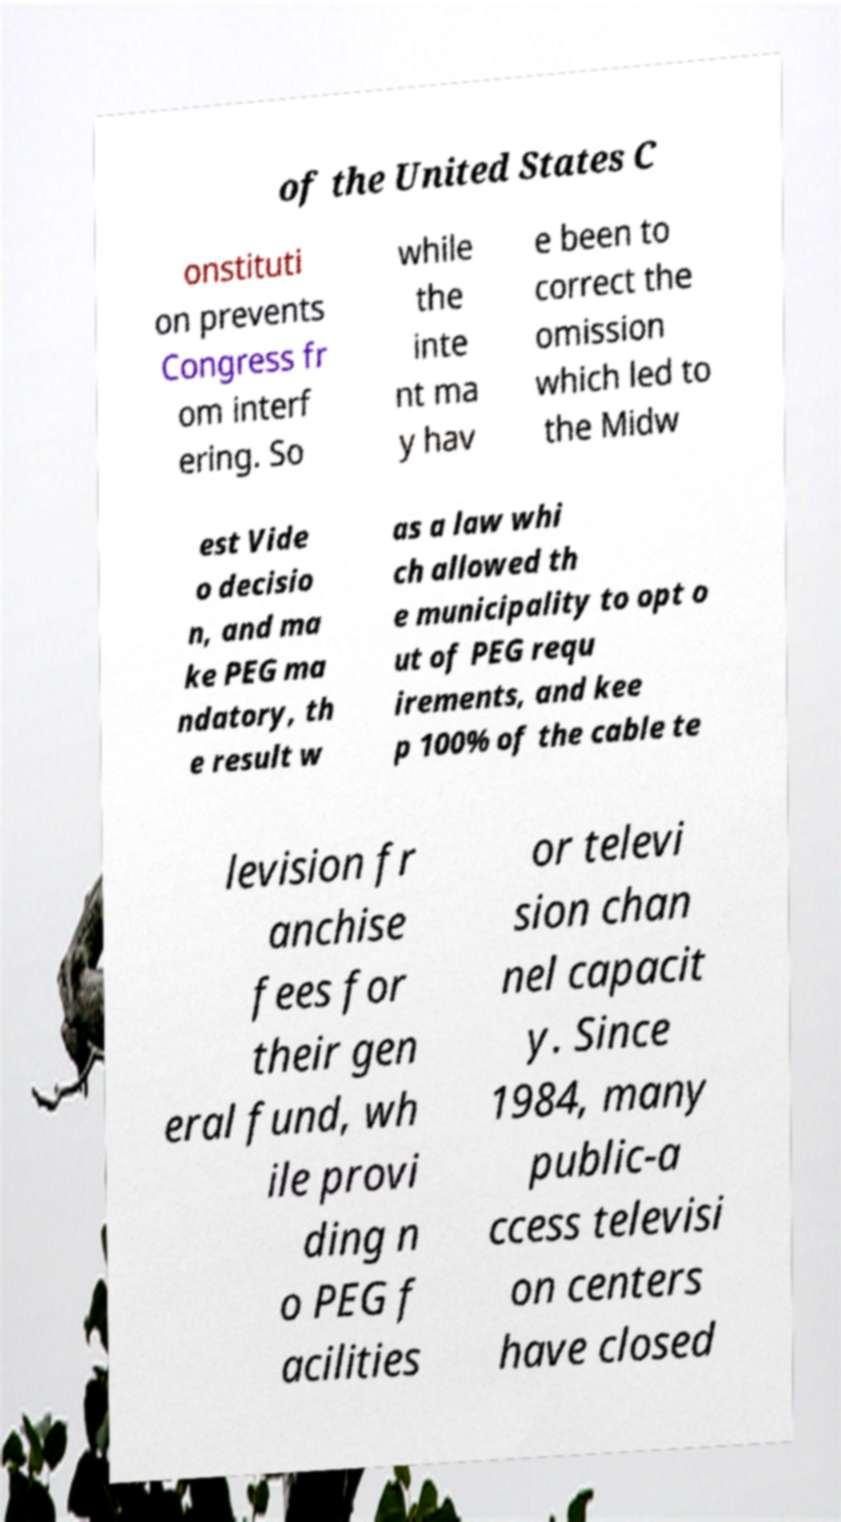What messages or text are displayed in this image? I need them in a readable, typed format. of the United States C onstituti on prevents Congress fr om interf ering. So while the inte nt ma y hav e been to correct the omission which led to the Midw est Vide o decisio n, and ma ke PEG ma ndatory, th e result w as a law whi ch allowed th e municipality to opt o ut of PEG requ irements, and kee p 100% of the cable te levision fr anchise fees for their gen eral fund, wh ile provi ding n o PEG f acilities or televi sion chan nel capacit y. Since 1984, many public-a ccess televisi on centers have closed 